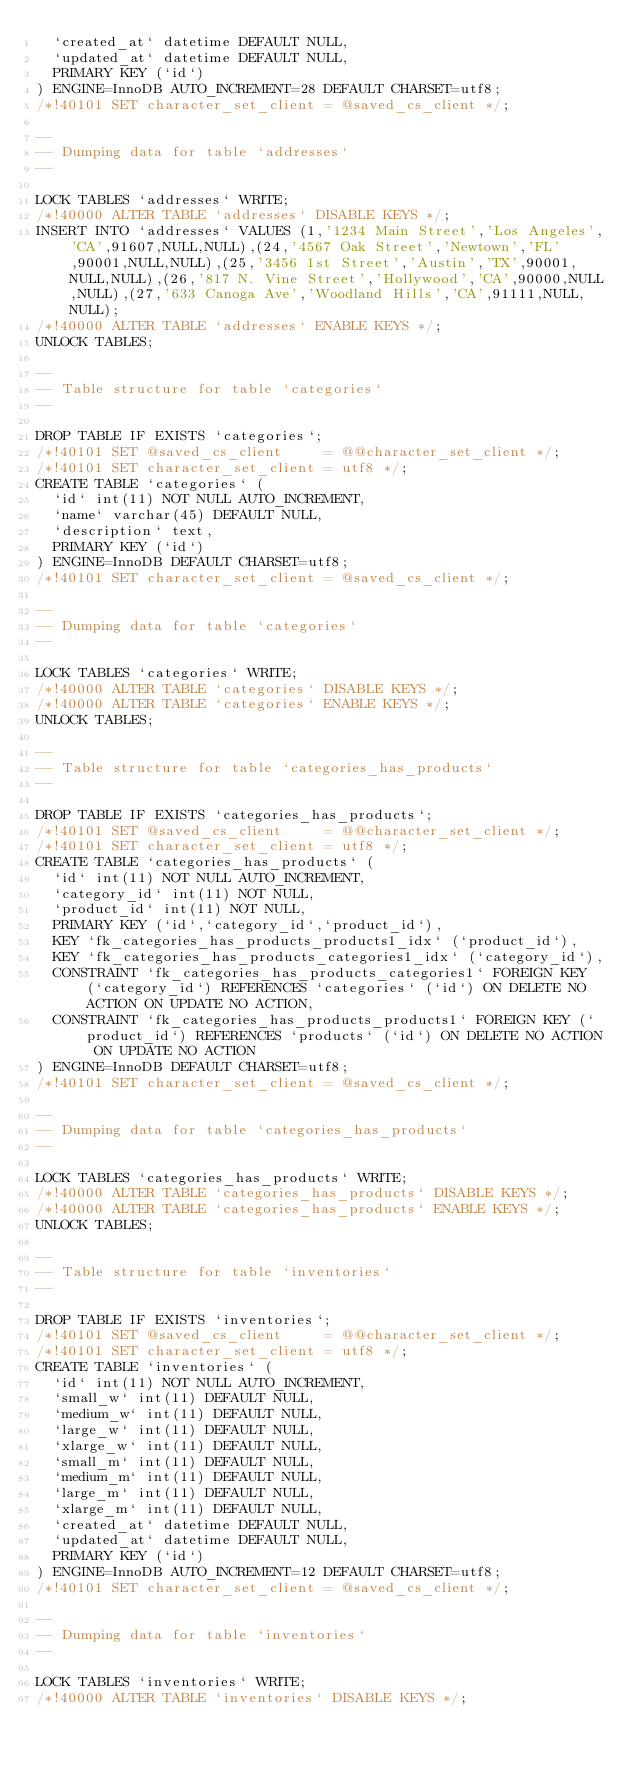<code> <loc_0><loc_0><loc_500><loc_500><_SQL_>  `created_at` datetime DEFAULT NULL,
  `updated_at` datetime DEFAULT NULL,
  PRIMARY KEY (`id`)
) ENGINE=InnoDB AUTO_INCREMENT=28 DEFAULT CHARSET=utf8;
/*!40101 SET character_set_client = @saved_cs_client */;

--
-- Dumping data for table `addresses`
--

LOCK TABLES `addresses` WRITE;
/*!40000 ALTER TABLE `addresses` DISABLE KEYS */;
INSERT INTO `addresses` VALUES (1,'1234 Main Street','Los Angeles','CA',91607,NULL,NULL),(24,'4567 Oak Street','Newtown','FL',90001,NULL,NULL),(25,'3456 1st Street','Austin','TX',90001,NULL,NULL),(26,'817 N. Vine Street','Hollywood','CA',90000,NULL,NULL),(27,'633 Canoga Ave','Woodland Hills','CA',91111,NULL,NULL);
/*!40000 ALTER TABLE `addresses` ENABLE KEYS */;
UNLOCK TABLES;

--
-- Table structure for table `categories`
--

DROP TABLE IF EXISTS `categories`;
/*!40101 SET @saved_cs_client     = @@character_set_client */;
/*!40101 SET character_set_client = utf8 */;
CREATE TABLE `categories` (
  `id` int(11) NOT NULL AUTO_INCREMENT,
  `name` varchar(45) DEFAULT NULL,
  `description` text,
  PRIMARY KEY (`id`)
) ENGINE=InnoDB DEFAULT CHARSET=utf8;
/*!40101 SET character_set_client = @saved_cs_client */;

--
-- Dumping data for table `categories`
--

LOCK TABLES `categories` WRITE;
/*!40000 ALTER TABLE `categories` DISABLE KEYS */;
/*!40000 ALTER TABLE `categories` ENABLE KEYS */;
UNLOCK TABLES;

--
-- Table structure for table `categories_has_products`
--

DROP TABLE IF EXISTS `categories_has_products`;
/*!40101 SET @saved_cs_client     = @@character_set_client */;
/*!40101 SET character_set_client = utf8 */;
CREATE TABLE `categories_has_products` (
  `id` int(11) NOT NULL AUTO_INCREMENT,
  `category_id` int(11) NOT NULL,
  `product_id` int(11) NOT NULL,
  PRIMARY KEY (`id`,`category_id`,`product_id`),
  KEY `fk_categories_has_products_products1_idx` (`product_id`),
  KEY `fk_categories_has_products_categories1_idx` (`category_id`),
  CONSTRAINT `fk_categories_has_products_categories1` FOREIGN KEY (`category_id`) REFERENCES `categories` (`id`) ON DELETE NO ACTION ON UPDATE NO ACTION,
  CONSTRAINT `fk_categories_has_products_products1` FOREIGN KEY (`product_id`) REFERENCES `products` (`id`) ON DELETE NO ACTION ON UPDATE NO ACTION
) ENGINE=InnoDB DEFAULT CHARSET=utf8;
/*!40101 SET character_set_client = @saved_cs_client */;

--
-- Dumping data for table `categories_has_products`
--

LOCK TABLES `categories_has_products` WRITE;
/*!40000 ALTER TABLE `categories_has_products` DISABLE KEYS */;
/*!40000 ALTER TABLE `categories_has_products` ENABLE KEYS */;
UNLOCK TABLES;

--
-- Table structure for table `inventories`
--

DROP TABLE IF EXISTS `inventories`;
/*!40101 SET @saved_cs_client     = @@character_set_client */;
/*!40101 SET character_set_client = utf8 */;
CREATE TABLE `inventories` (
  `id` int(11) NOT NULL AUTO_INCREMENT,
  `small_w` int(11) DEFAULT NULL,
  `medium_w` int(11) DEFAULT NULL,
  `large_w` int(11) DEFAULT NULL,
  `xlarge_w` int(11) DEFAULT NULL,
  `small_m` int(11) DEFAULT NULL,
  `medium_m` int(11) DEFAULT NULL,
  `large_m` int(11) DEFAULT NULL,
  `xlarge_m` int(11) DEFAULT NULL,
  `created_at` datetime DEFAULT NULL,
  `updated_at` datetime DEFAULT NULL,
  PRIMARY KEY (`id`)
) ENGINE=InnoDB AUTO_INCREMENT=12 DEFAULT CHARSET=utf8;
/*!40101 SET character_set_client = @saved_cs_client */;

--
-- Dumping data for table `inventories`
--

LOCK TABLES `inventories` WRITE;
/*!40000 ALTER TABLE `inventories` DISABLE KEYS */;</code> 